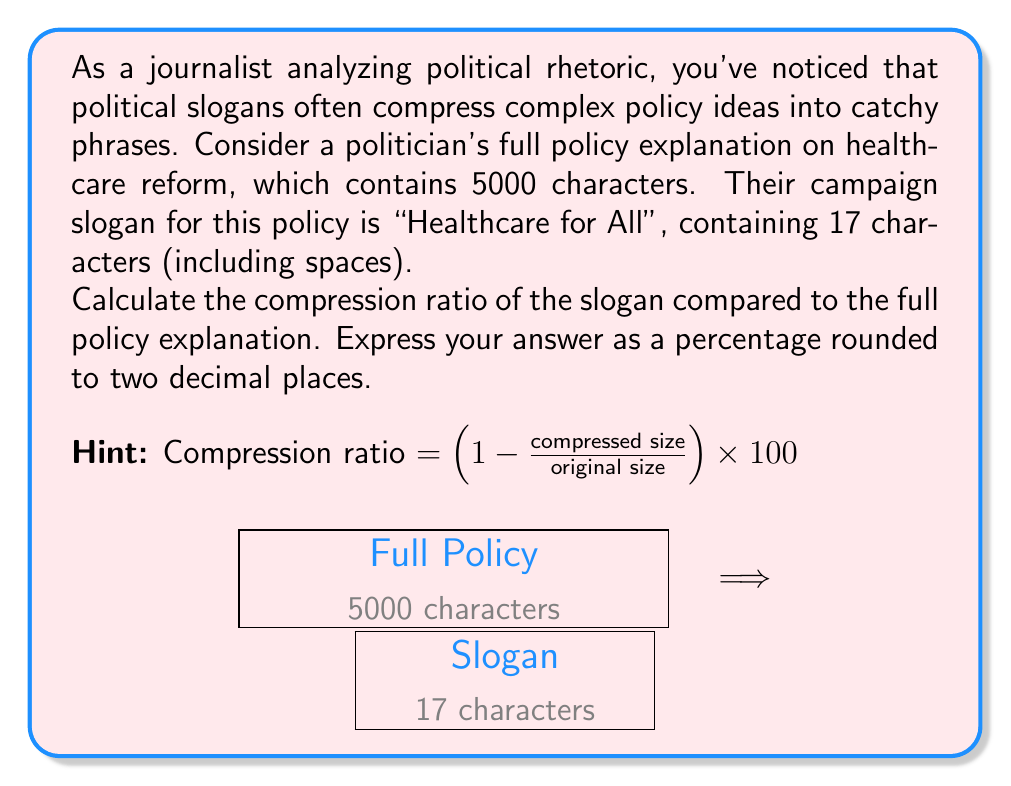Can you answer this question? To solve this problem, we'll follow these steps:

1) Identify the original size and compressed size:
   Original size (full policy explanation) = 5000 characters
   Compressed size (slogan) = 17 characters

2) Apply the compression ratio formula:
   Compression ratio = (1 - compressed size / original size) * 100

3) Plug in the values:
   Compression ratio = (1 - 17 / 5000) * 100

4) Perform the division inside the parentheses:
   Compression ratio = (1 - 0.0034) * 100

5) Subtract:
   Compression ratio = 0.9966 * 100

6) Multiply:
   Compression ratio = 99.66%

7) Round to two decimal places:
   The result is already rounded to two decimal places, so no further rounding is needed.

Therefore, the compression ratio is 99.66%.

This high compression ratio demonstrates how political slogans can drastically reduce complex policy explanations into short, memorable phrases, which is a common tactic in political rhetoric.
Answer: 99.66% 